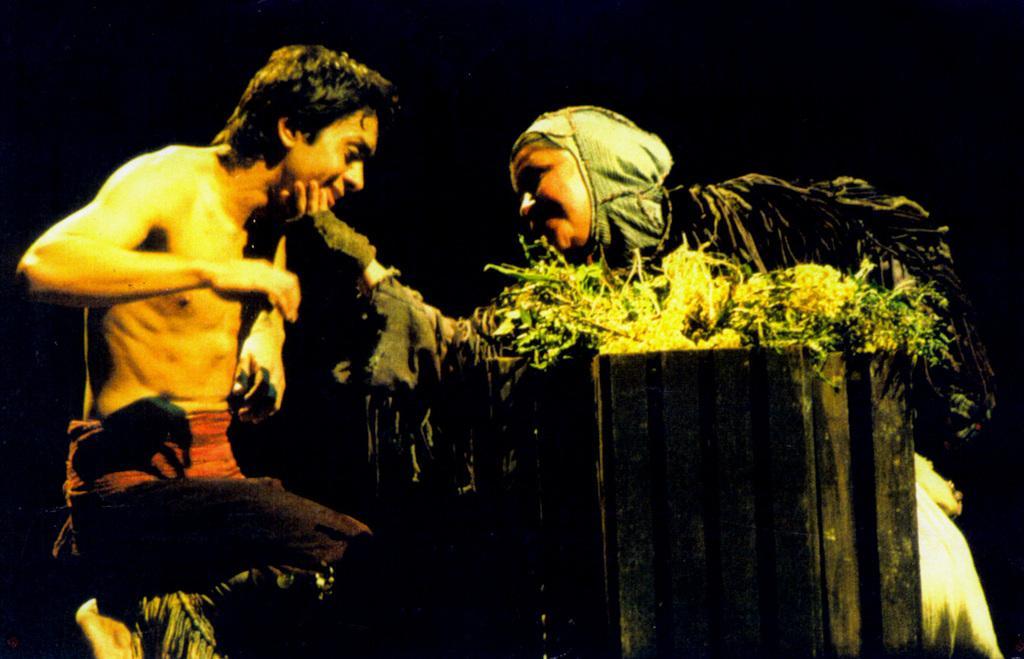Could you give a brief overview of what you see in this image? Here in this picture on the right side we can see an old women present over there and in front of her we can see a person present and she is holding his face and both of them are smiling and in between them we can see a wooden wall and a plant present over there. 